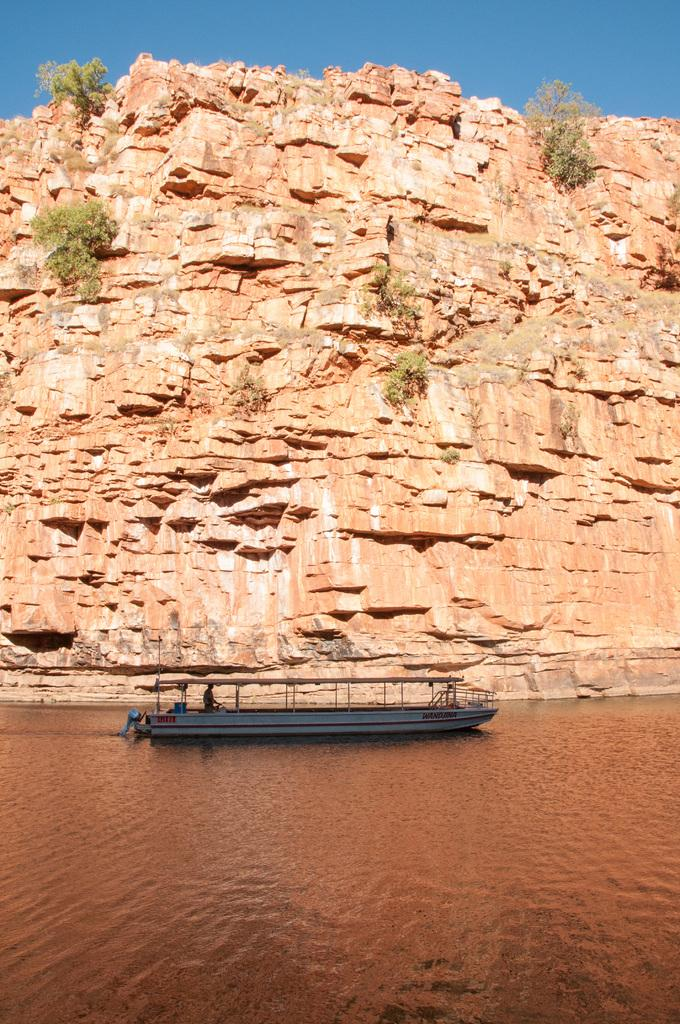What is the main subject of the image? The main subject of the image is a boat. Where is the boat located? The boat is on the water. What else can be seen in the image besides the boat? There are plants on a rock in the image. What is visible in the background of the image? The sky is visible in the background of the image. What type of cork can be seen floating near the boat in the image? There is no cork visible in the image; it only features a boat, plants on a rock, and the sky. 